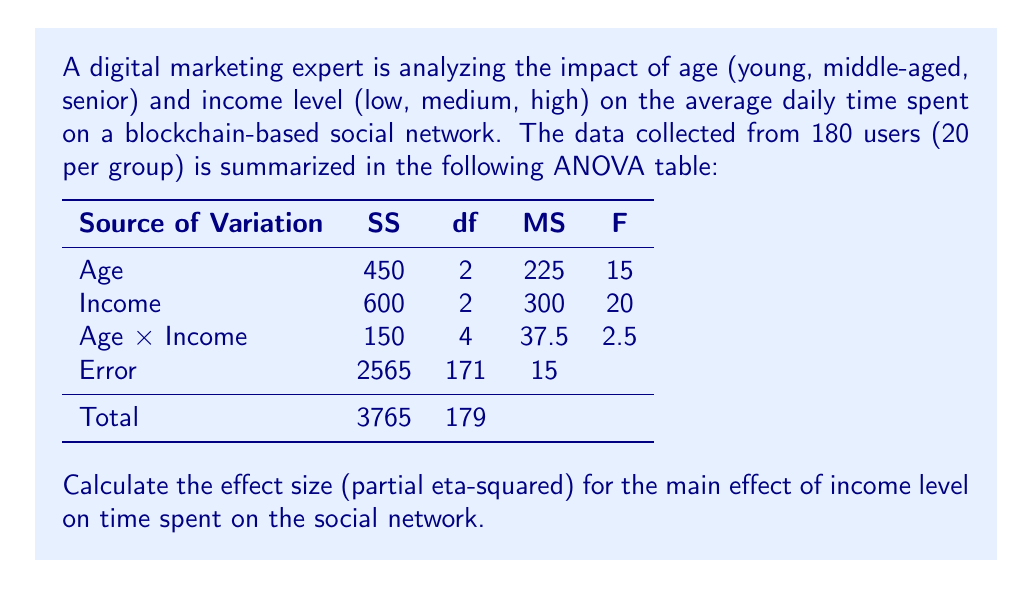Can you solve this math problem? To calculate the partial eta-squared ($\eta_p^2$) for the main effect of income level, we need to use the following formula:

$$\eta_p^2 = \frac{SS_{effect}}{SS_{effect} + SS_{error}}$$

Where:
$SS_{effect}$ is the Sum of Squares for the effect (income in this case)
$SS_{error}$ is the Sum of Squares for the error

From the ANOVA table, we can identify:
$SS_{income} = 600$
$SS_{error} = 2565$

Now, let's substitute these values into the formula:

$$\eta_p^2 = \frac{600}{600 + 2565}$$

$$\eta_p^2 = \frac{600}{3165}$$

$$\eta_p^2 \approx 0.1896$$

To convert this to a percentage, we multiply by 100:

$$\eta_p^2 \approx 0.1896 \times 100 = 18.96\%$$

This means that approximately 18.96% of the variance in time spent on the blockchain-based social network can be accounted for by the main effect of income level, when controlling for the effects of age and the interaction between age and income.
Answer: $\eta_p^2 \approx 0.1896$ or 18.96% 